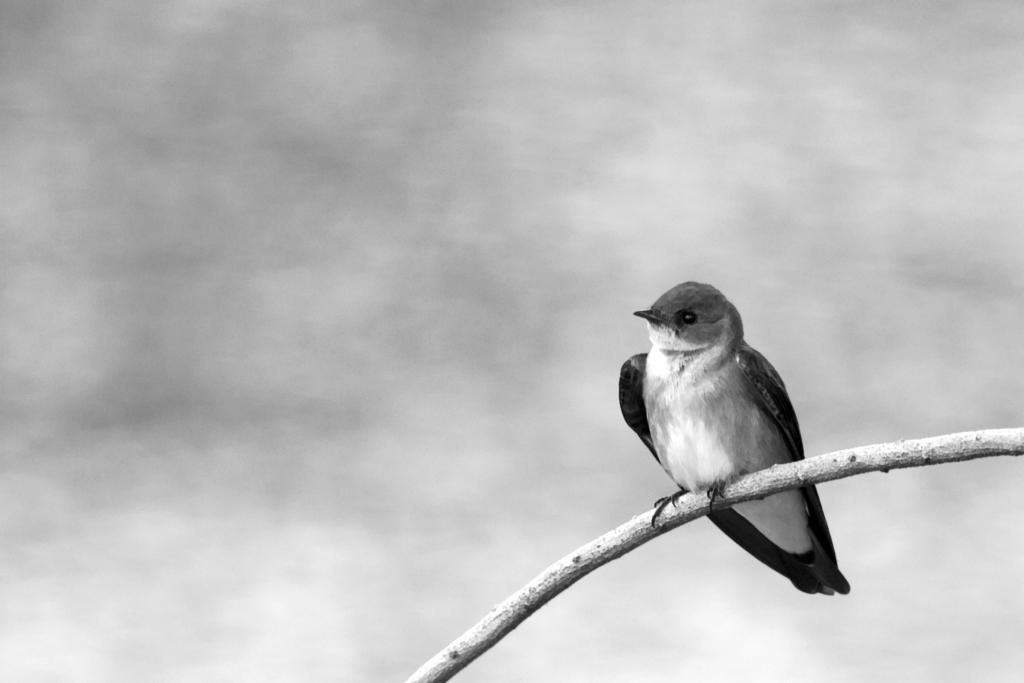What type of animal can be seen in the image? There is a bird in the image. Where is the bird located in the image? The bird is sitting on a branch. What is the branch a part of? The branch is part of a tree or plant. What type of square object can be seen in the image? There is no square object present in the image; it features a bird sitting on a branch that is part of a tree or plant. 